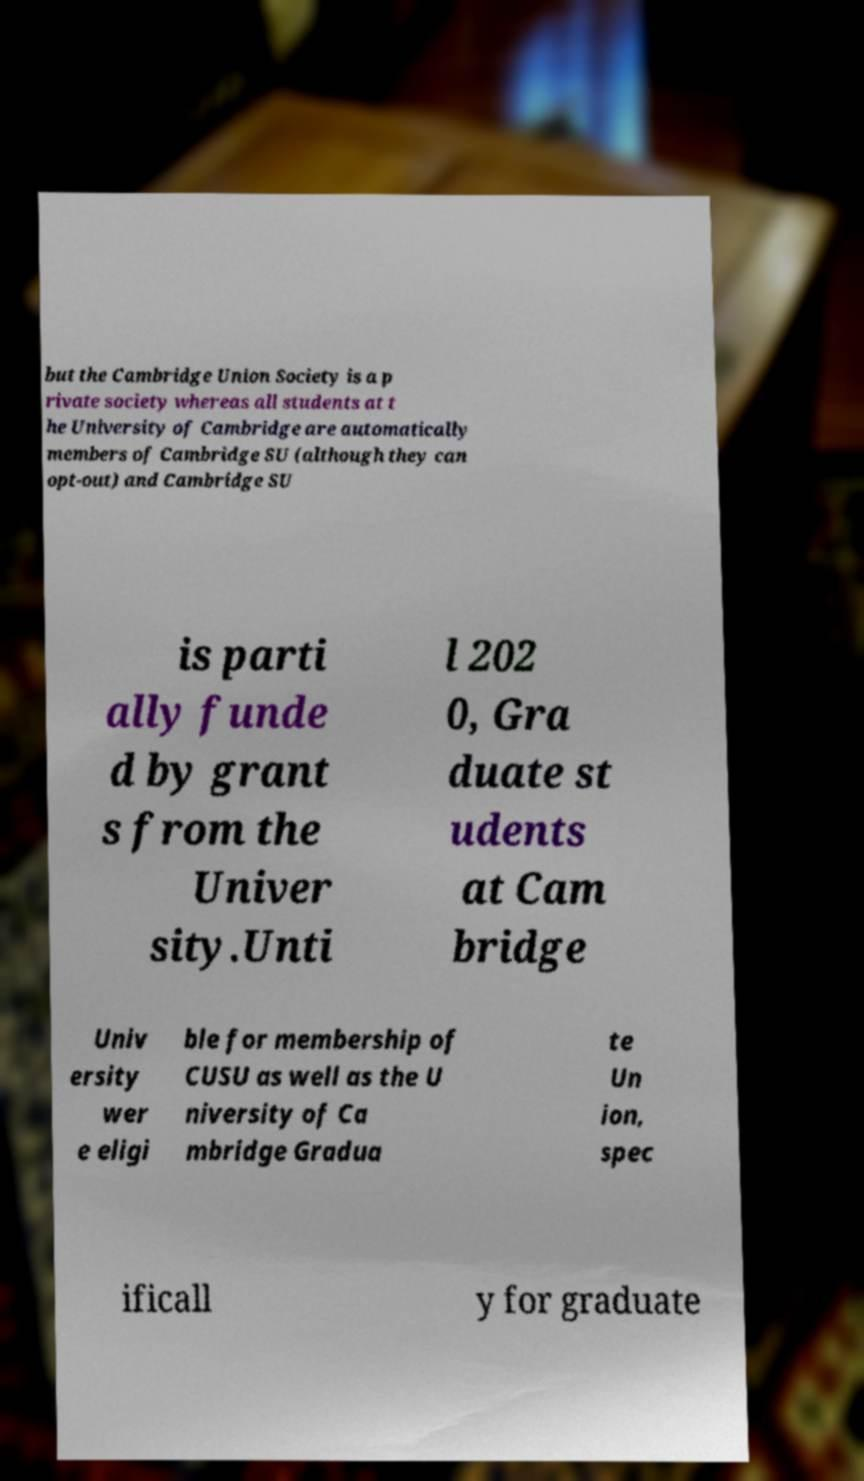Can you read and provide the text displayed in the image?This photo seems to have some interesting text. Can you extract and type it out for me? but the Cambridge Union Society is a p rivate society whereas all students at t he University of Cambridge are automatically members of Cambridge SU (although they can opt-out) and Cambridge SU is parti ally funde d by grant s from the Univer sity.Unti l 202 0, Gra duate st udents at Cam bridge Univ ersity wer e eligi ble for membership of CUSU as well as the U niversity of Ca mbridge Gradua te Un ion, spec ificall y for graduate 